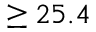Convert formula to latex. <formula><loc_0><loc_0><loc_500><loc_500>\geq 2 5 . 4</formula> 